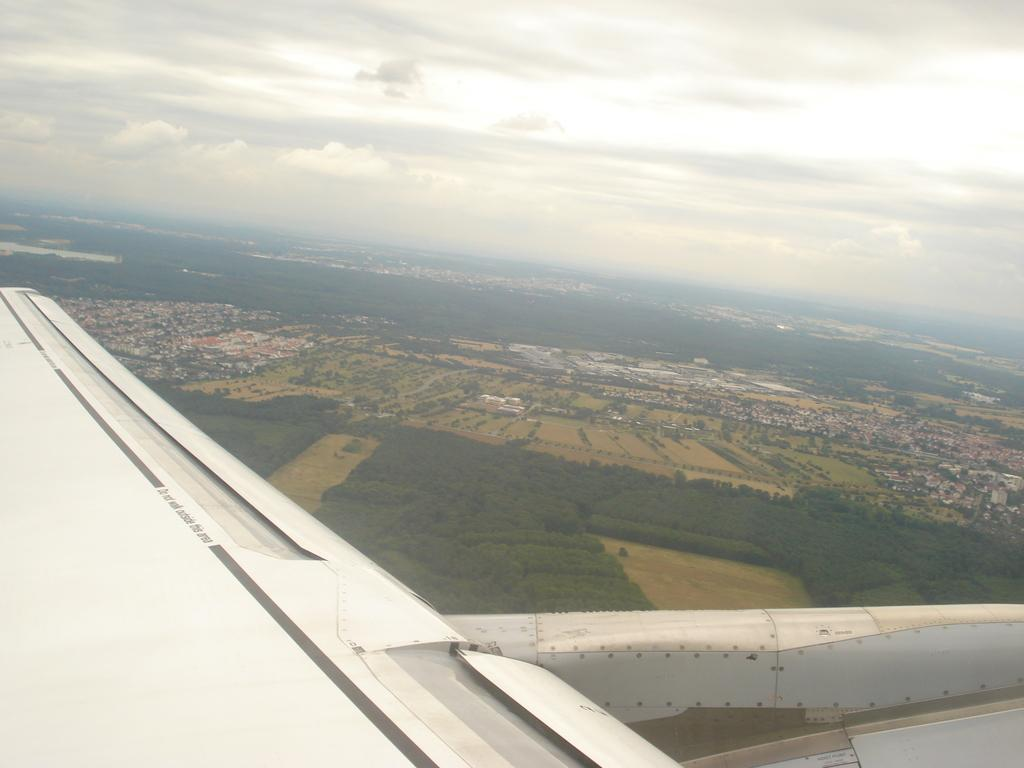What is the primary color of the surface in the image? The surface in the image is white. What type of vegetation can be seen on the ground? Greenery is visible on the ground. How would you describe the sky in the image? The sky is cloudy in the image. What discovery did the brothers make after the aftermath of the storm in the image? There is no mention of a storm, brothers, or any discovery in the image. The image only shows a white surface, greenery on the ground, and a cloudy sky. 